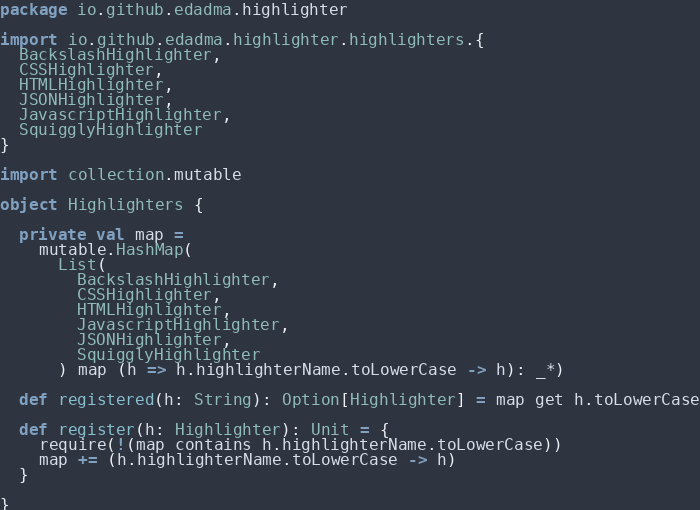<code> <loc_0><loc_0><loc_500><loc_500><_Scala_>package io.github.edadma.highlighter

import io.github.edadma.highlighter.highlighters.{
  BackslashHighlighter,
  CSSHighlighter,
  HTMLHighlighter,
  JSONHighlighter,
  JavascriptHighlighter,
  SquigglyHighlighter
}

import collection.mutable

object Highlighters {

  private val map =
    mutable.HashMap(
      List(
        BackslashHighlighter,
        CSSHighlighter,
        HTMLHighlighter,
        JavascriptHighlighter,
        JSONHighlighter,
        SquigglyHighlighter
      ) map (h => h.highlighterName.toLowerCase -> h): _*)

  def registered(h: String): Option[Highlighter] = map get h.toLowerCase

  def register(h: Highlighter): Unit = {
    require(!(map contains h.highlighterName.toLowerCase))
    map += (h.highlighterName.toLowerCase -> h)
  }

}
</code> 